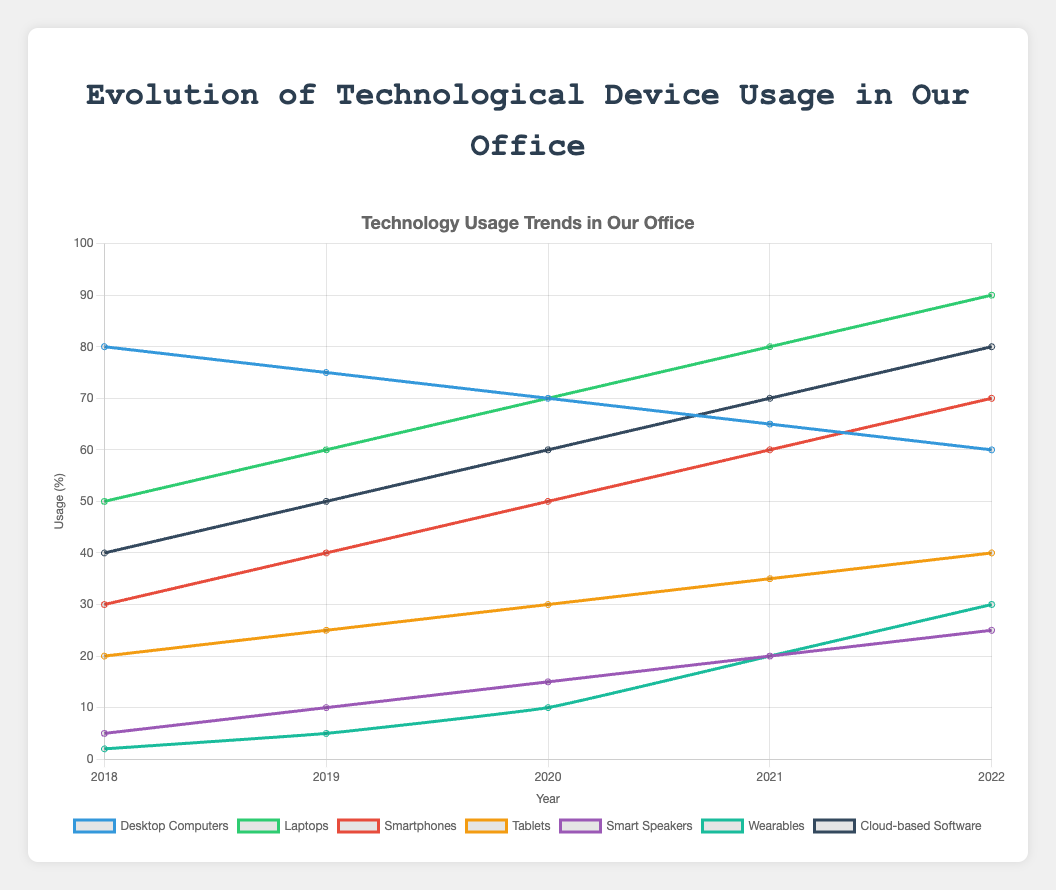Which technological device saw the biggest increase in usage from 2018 to 2022? Calculate the difference in usage percentage for each device from 2018 to 2022: Desktop Computers (60 - 80 = -20), Laptops (90 - 50 = 40), Smartphones (70 - 30 = 40), Tablets (40 - 20 = 20), Smart Speakers (25 - 5 = 20), Wearables (30 - 2 = 28), Cloud-Based Software (80 - 40 = 40). Desktop Computers decreased by 20%, Laptops, Smartphones, and Cloud-Based Software increased by 40%, Wearables increased by 28%, and Smart Speakers increased by 20%.
Answer: Laptops, Smartphones, and Cloud-Based Software Which device's usage remained the lowest in 2022? Look at the endpoint of each line in 2022 and identify the lowest value. Wearables (30), Smart Speakers (25), Tablets (40), Smartphones (70), Laptops (90), Desktop Computers (60), Cloud-Based Software (80).
Answer: Smart Speakers What is the difference in usage percentage of desktop computers and laptops in 2021? Locate the value for desktop computers and laptops in 2021: Desktop Computers (65) and Laptops (80). Calculate the difference (80 - 65).
Answer: 15% Which device had the highest usage increase between 2019 and 2020? Determine the usage difference for each device between 2019 and 2020: Desktop Computers (70 - 75 = -5), Laptops (70 - 60 = 10), Smartphones (50 - 40 = 10), Tablets (30 - 25 = 5), Smart Speakers (15 - 10 = 5), Wearables (10 - 5 = 5), Cloud-Based Software (60 - 50 = 10). Desktop Computers decreased by 5%, and all others increased with Laptops, Smartphones, and Cloud-Based Software increasing by 10%.
Answer: Laptops, Smartphones, and Cloud-Based Software What was the combined usage percentage of smartphones, tablets, and wearables in 2020? Identify the values for each device in 2020: Smartphones (50), Tablets (30), Wearables (10). Sum the three values (50 + 30 + 10).
Answer: 90% By how much did the usage of cloud-based software increase from 2018 to 2022? Identify the usage percentage of cloud-based software for 2018 and 2022: 2018 (40), 2022 (80). Calculate the increase (80 - 40).
Answer: 40 Which two devices have the most similar usage percentage in 2020? Review the usage percentages for 2020: Desktop Computers (70), Laptops (70), Smartphones (50), Tablets (30), Smart Speakers (15), Wearables (10), Cloud-Based Software (60). Compare the values to identify the closest two: Desktop Computers and Laptops both have 70%.
Answer: Desktop Computers and Laptops What is the average usage percentage of smart speakers from 2018 to 2022? Identify the usage percentages for each year: 2018 (5), 2019 (10), 2020 (15), 2021 (20), 2022 (25). Calculate the sum (5 + 10 + 15 + 20 + 25) = 75, and find the average (75/5).
Answer: 15% Between which years did the usage of tablets show the greatest increase? Determine the difference year-by-year: 2018-2019 (25 - 20 = 5), 2019-2020 (30 - 25 = 5), 2020-2021 (35 - 30 = 5), 2021-2022 (40 - 35 = 5). The difference is the same (5%) for each interval.
Answer: All intervals equal What's the sum of desktop computer usage and cloud-based software usage in 2021? Identify the usage percentages for desktop computers and cloud-based software in 2021: Desktop Computers (65), Cloud-Based Software (70). Calculate the sum (65 + 70).
Answer: 135 